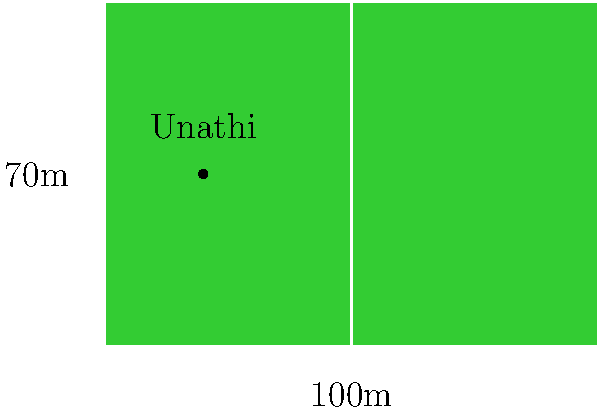As you discuss the upcoming match with your friend Unathi Mali at the rugby field, you both wonder about its size. The field measures 100 meters in length and 70 meters in width. What is the total area of the rugby field in square meters? To calculate the area of the rugby field, we need to use the formula for the area of a rectangle:

$$A = l \times w$$

Where:
$A$ = Area
$l$ = Length
$w$ = Width

Given:
Length ($l$) = 100 meters
Width ($w$) = 70 meters

Let's substitute these values into the formula:

$$A = 100 \text{ m} \times 70 \text{ m}$$

Now, let's multiply:

$$A = 7000 \text{ m}^2$$

Therefore, the total area of the rugby field is 7000 square meters.
Answer: 7000 m² 